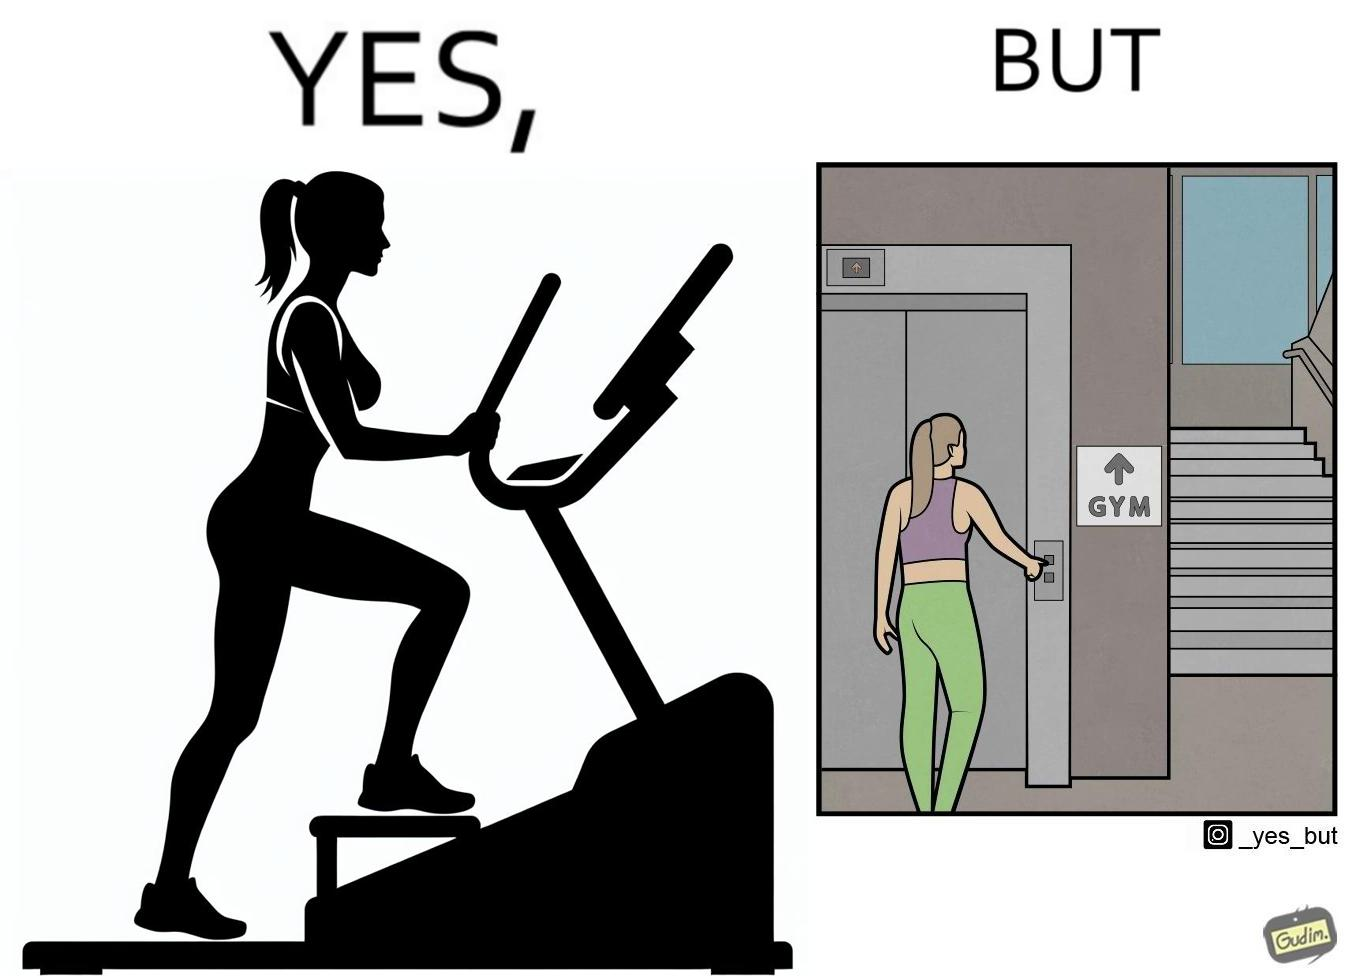Is this a satirical image? Yes, this image is satirical. 